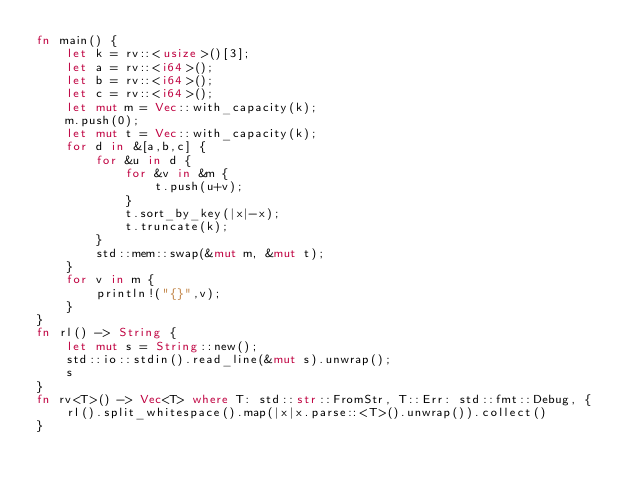<code> <loc_0><loc_0><loc_500><loc_500><_Rust_>fn main() {
    let k = rv::<usize>()[3];
    let a = rv::<i64>();
    let b = rv::<i64>();
    let c = rv::<i64>();
    let mut m = Vec::with_capacity(k);
    m.push(0);
    let mut t = Vec::with_capacity(k);
    for d in &[a,b,c] {
        for &u in d {
            for &v in &m {
                t.push(u+v);
            }
            t.sort_by_key(|x|-x);
            t.truncate(k);
        }
        std::mem::swap(&mut m, &mut t);
    }
    for v in m {
        println!("{}",v);
    }
}
fn rl() -> String {
    let mut s = String::new();
    std::io::stdin().read_line(&mut s).unwrap();
    s
}
fn rv<T>() -> Vec<T> where T: std::str::FromStr, T::Err: std::fmt::Debug, {
    rl().split_whitespace().map(|x|x.parse::<T>().unwrap()).collect()
}</code> 